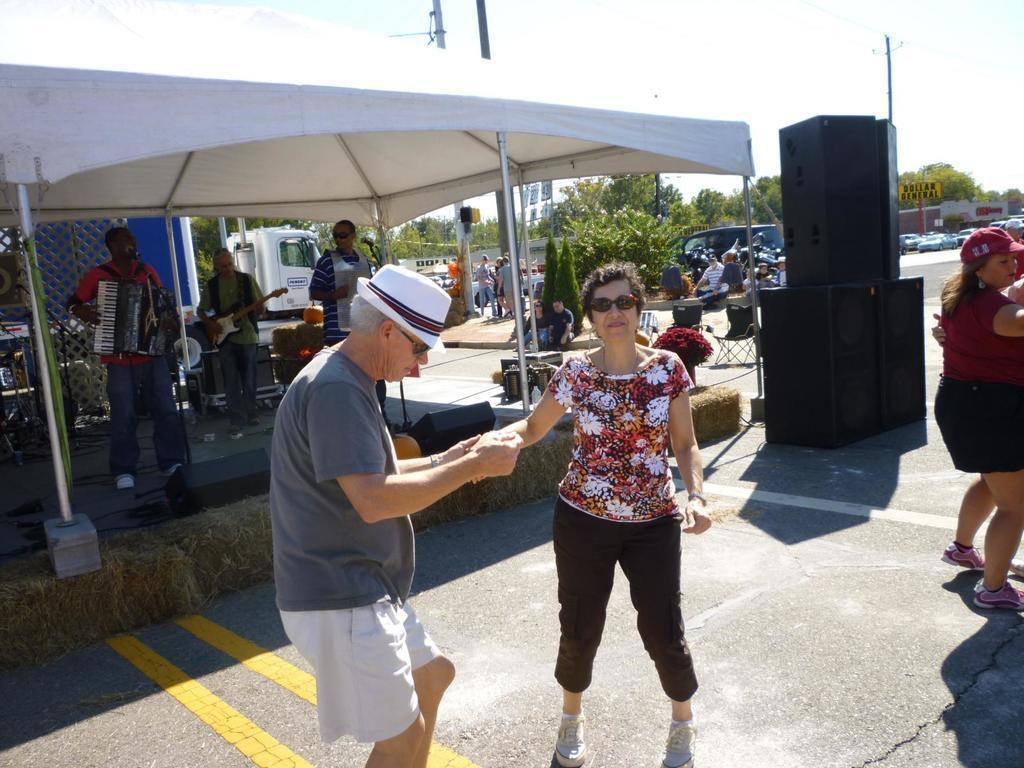How would you summarize this image in a sentence or two? This image is taken outdoors. At the bottom of the image there is a road. In the background there are many trees and a few plants. Many cars are parked on the road. A few people are standing on the road and a few are sitting. On the right side of the image there is a woman and there are a few speaker boxes. On the left side of the image there is a tent and a truck is parked on the road. There is a dais. Three men are standing on the dais and playing music with musical instruments and there is a mic. In the middle of the image a woman and a man are standing on the road 